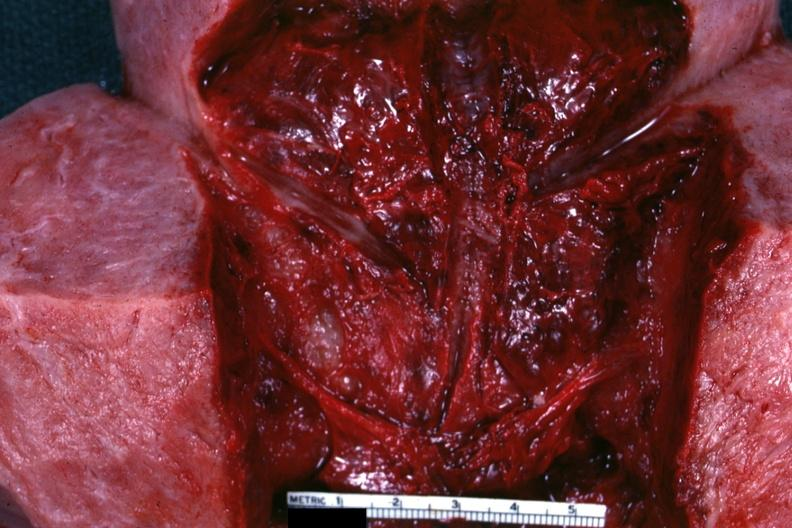does this image show close-up view of endometrial surface 18 hours after a cesarean section?
Answer the question using a single word or phrase. Yes 